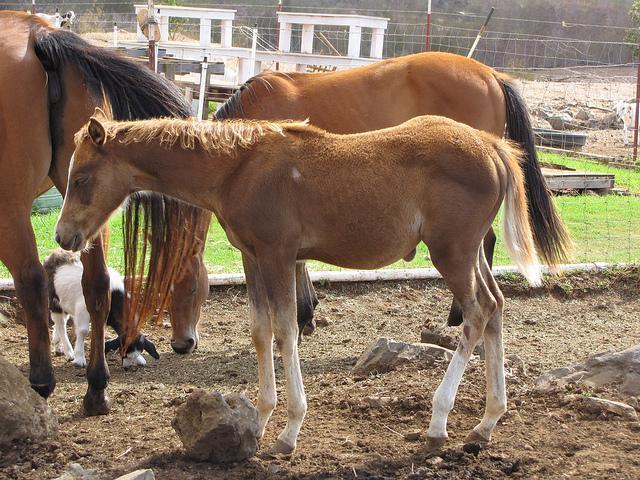How many horses are in the picture?
Give a very brief answer. 3. 